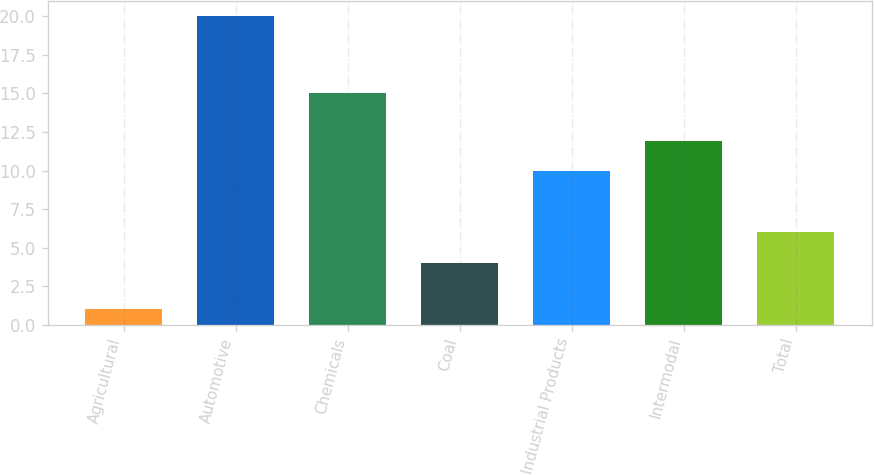Convert chart. <chart><loc_0><loc_0><loc_500><loc_500><bar_chart><fcel>Agricultural<fcel>Automotive<fcel>Chemicals<fcel>Coal<fcel>Industrial Products<fcel>Intermodal<fcel>Total<nl><fcel>1<fcel>20<fcel>15<fcel>4<fcel>10<fcel>11.9<fcel>6<nl></chart> 